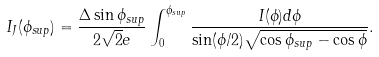<formula> <loc_0><loc_0><loc_500><loc_500>I _ { J } ( \phi _ { s u p } ) = \frac { \Delta \sin \phi _ { s u p } } { 2 \sqrt { 2 } e } \int _ { 0 } ^ { \phi _ { s u p } } \frac { I ( \phi ) d \phi } { \sin ( \phi / 2 ) \sqrt { \cos \phi _ { s u p } - \cos \phi } } .</formula> 